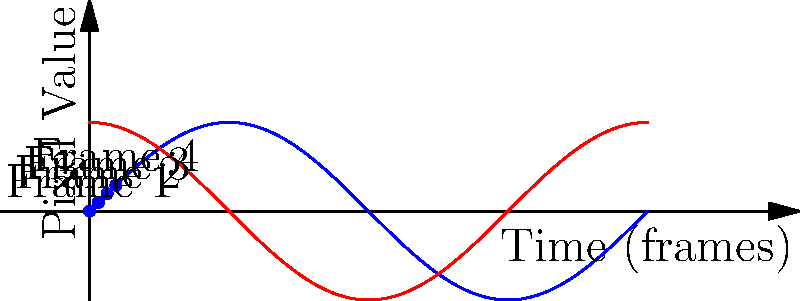In a Disney+ animation sequence of The Simpsons, the pixel values of a specific point follow a sinusoidal pattern over time. Given the blue curve represents the pixel values for the first 4 frames, what would be the most likely pixel value for frame 5? To predict the pixel value for frame 5, we need to analyze the pattern in the given sequence:

1. The blue curve represents a sine function, which has a period of $2\pi$.
2. We can see that the 4 given frames are equally spaced, each $\frac{\pi}{2}$ apart.
3. The frames correspond to the following points on the sine curve:
   - Frame 1: $\sin(0) = 0$
   - Frame 2: $\sin(\frac{\pi}{2}) = 1$
   - Frame 3: $\sin(\pi) = 0$
   - Frame 4: $\sin(\frac{3\pi}{2}) = -1$
4. To find frame 5, we need to calculate $\sin(2\pi)$.
5. We know that $\sin(2\pi) = \sin(0) = 0$.

Therefore, the pixel value for frame 5 would most likely be 0, completing one full cycle of the sine wave.
Answer: 0 